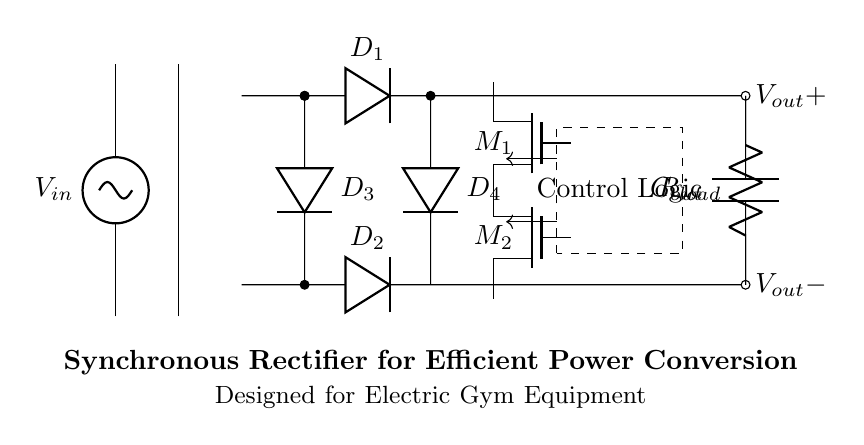What are the main components in this circuit? The main components include a transformer, diodes, MOSFETs, control logic, and output capacitor. Each of these plays a crucial role in converting AC to DC and regulating the output voltage in the circuit.
Answer: transformer, diodes, MOSFETs, control logic, capacitor What is the purpose of the MOSFETs in this rectifier circuit? The MOSFETs are used for synchronous rectification, which improves the efficiency of power conversion by reducing voltage drop and losses compared to conventional diodes. The MOSFETs are controlled to switch on and off to better conduct during the respective half-cycles of the AC input.
Answer: improve efficiency What type of rectification does this circuit perform? This circuit performs synchronous rectification, which is a technique that uses active devices like MOSFETs instead of standard diodes to achieve higher efficiency. The use of both the MOSFETs and diodes allows for more effective current flow.
Answer: synchronous rectification How does the control logic affect the operation of the rectifier? The control logic determines when the MOSFETs should be turned on and off to optimize the current flow through the circuit. By precisely timing the operation of the MOSFETs, the rectifier can enhance efficiency and minimize losses during both AC cycles.
Answer: optimizes current flow What is the significance of the output capacitor in this circuit? The output capacitor smooths the rectified voltage by filtering out ripple, providing a more stable DC output for the load connected across it. This is crucial for maintaining consistent performance in electric gym equipment powered by this rectifier.
Answer: smooths voltage 